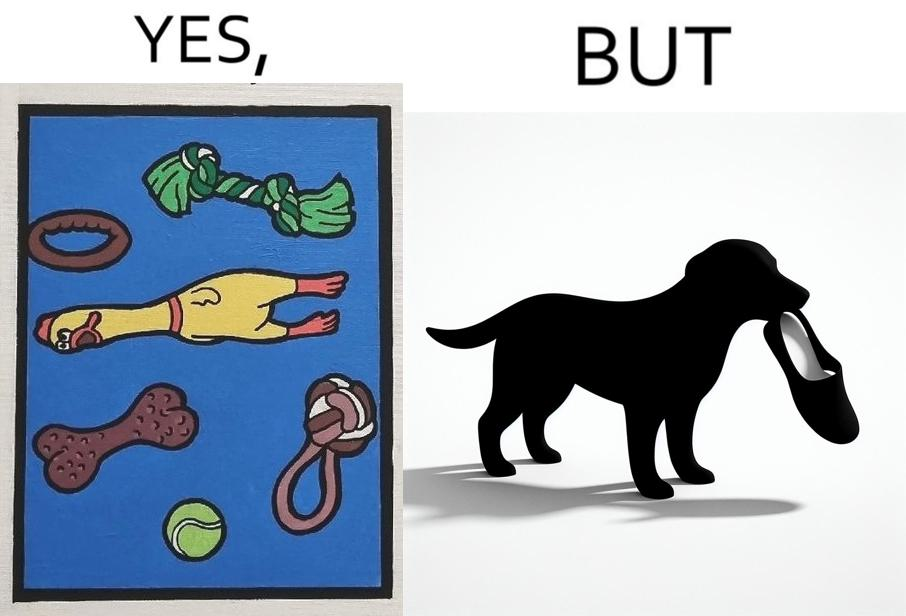Describe the contrast between the left and right parts of this image. In the left part of the image: a bunch of toys In the right part of the image: a dog holding a slipper 